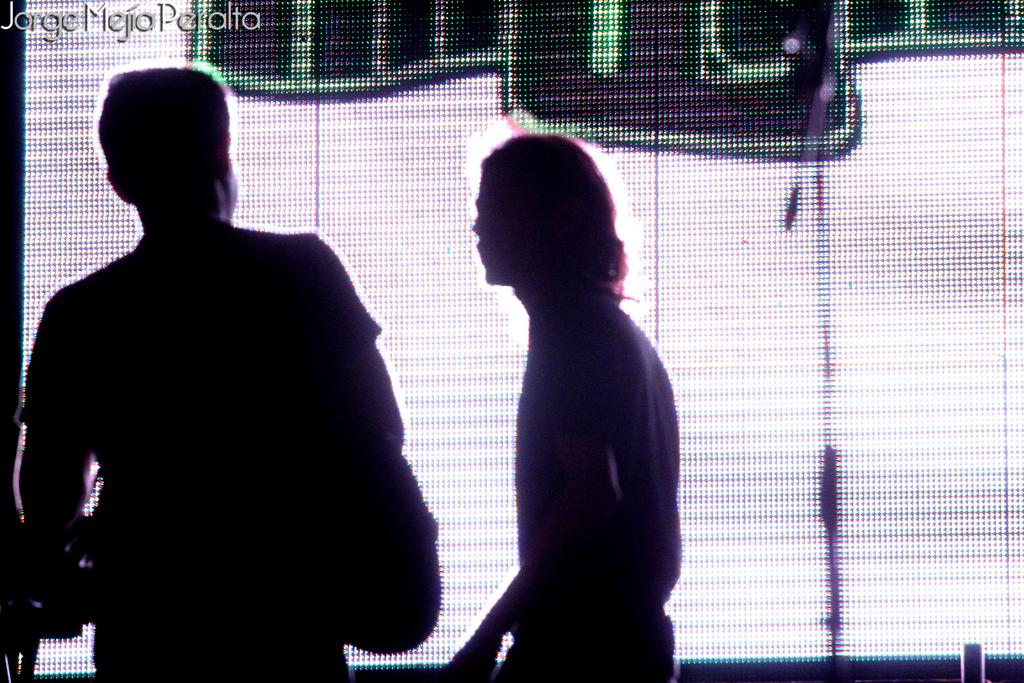How many people are present in the image? There are two persons standing in the image. What can be seen in the background of the image? There is a screen in the background of the image. Is there any additional information or marking on the image? Yes, there is a watermark at the top of the image. Can you tell me how many women are balancing on their tongues in the image? There are no women or any balancing acts involving tongues present in the image. 